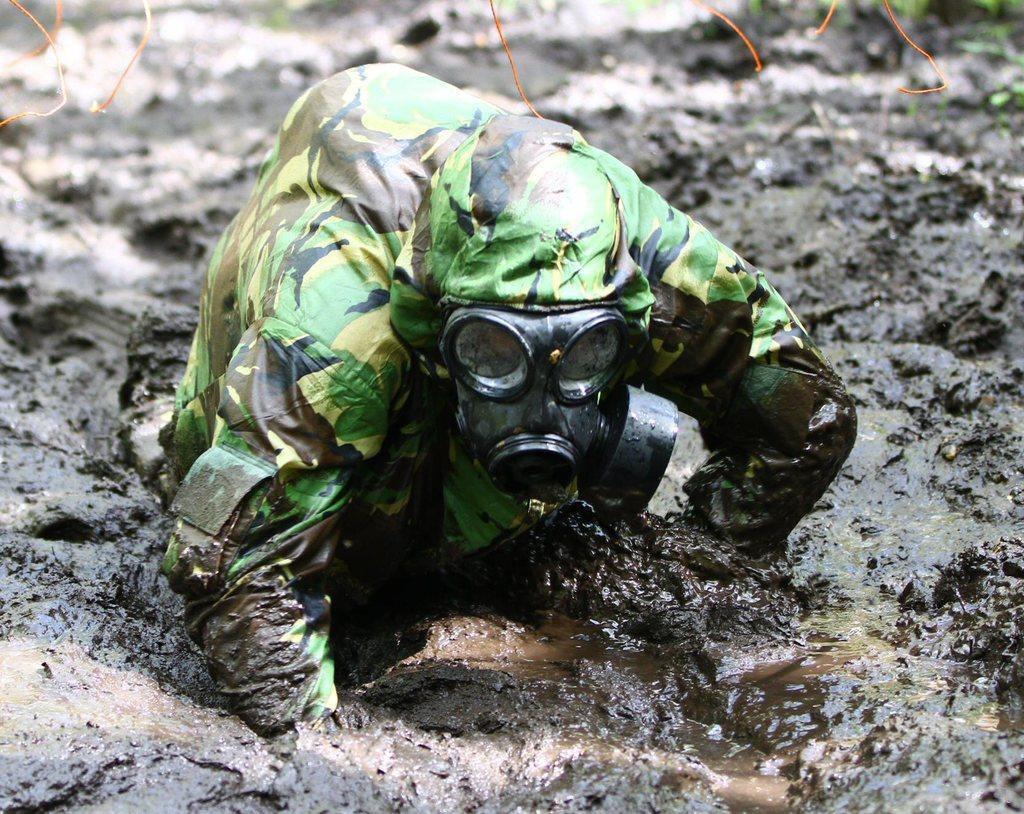Please provide a concise description of this image. In this image we can see a person. At the bottom of the image, we can see mud. 